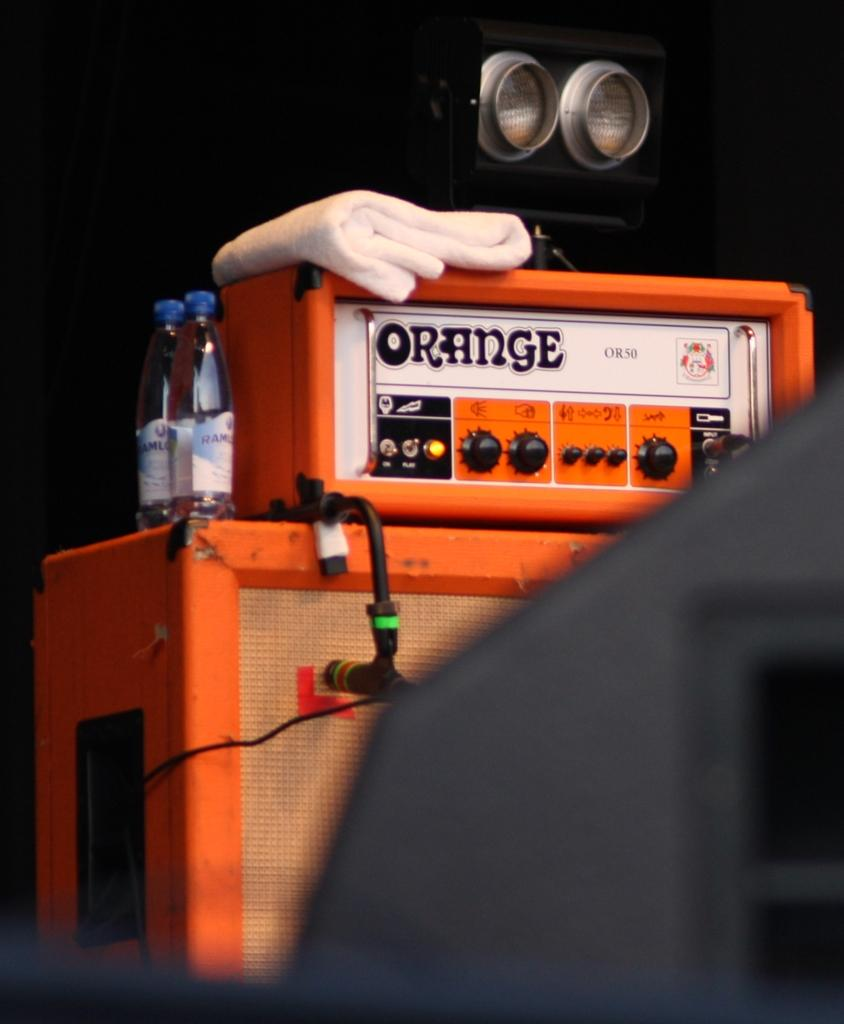<image>
Present a compact description of the photo's key features. An orange speaker says orange on the front 